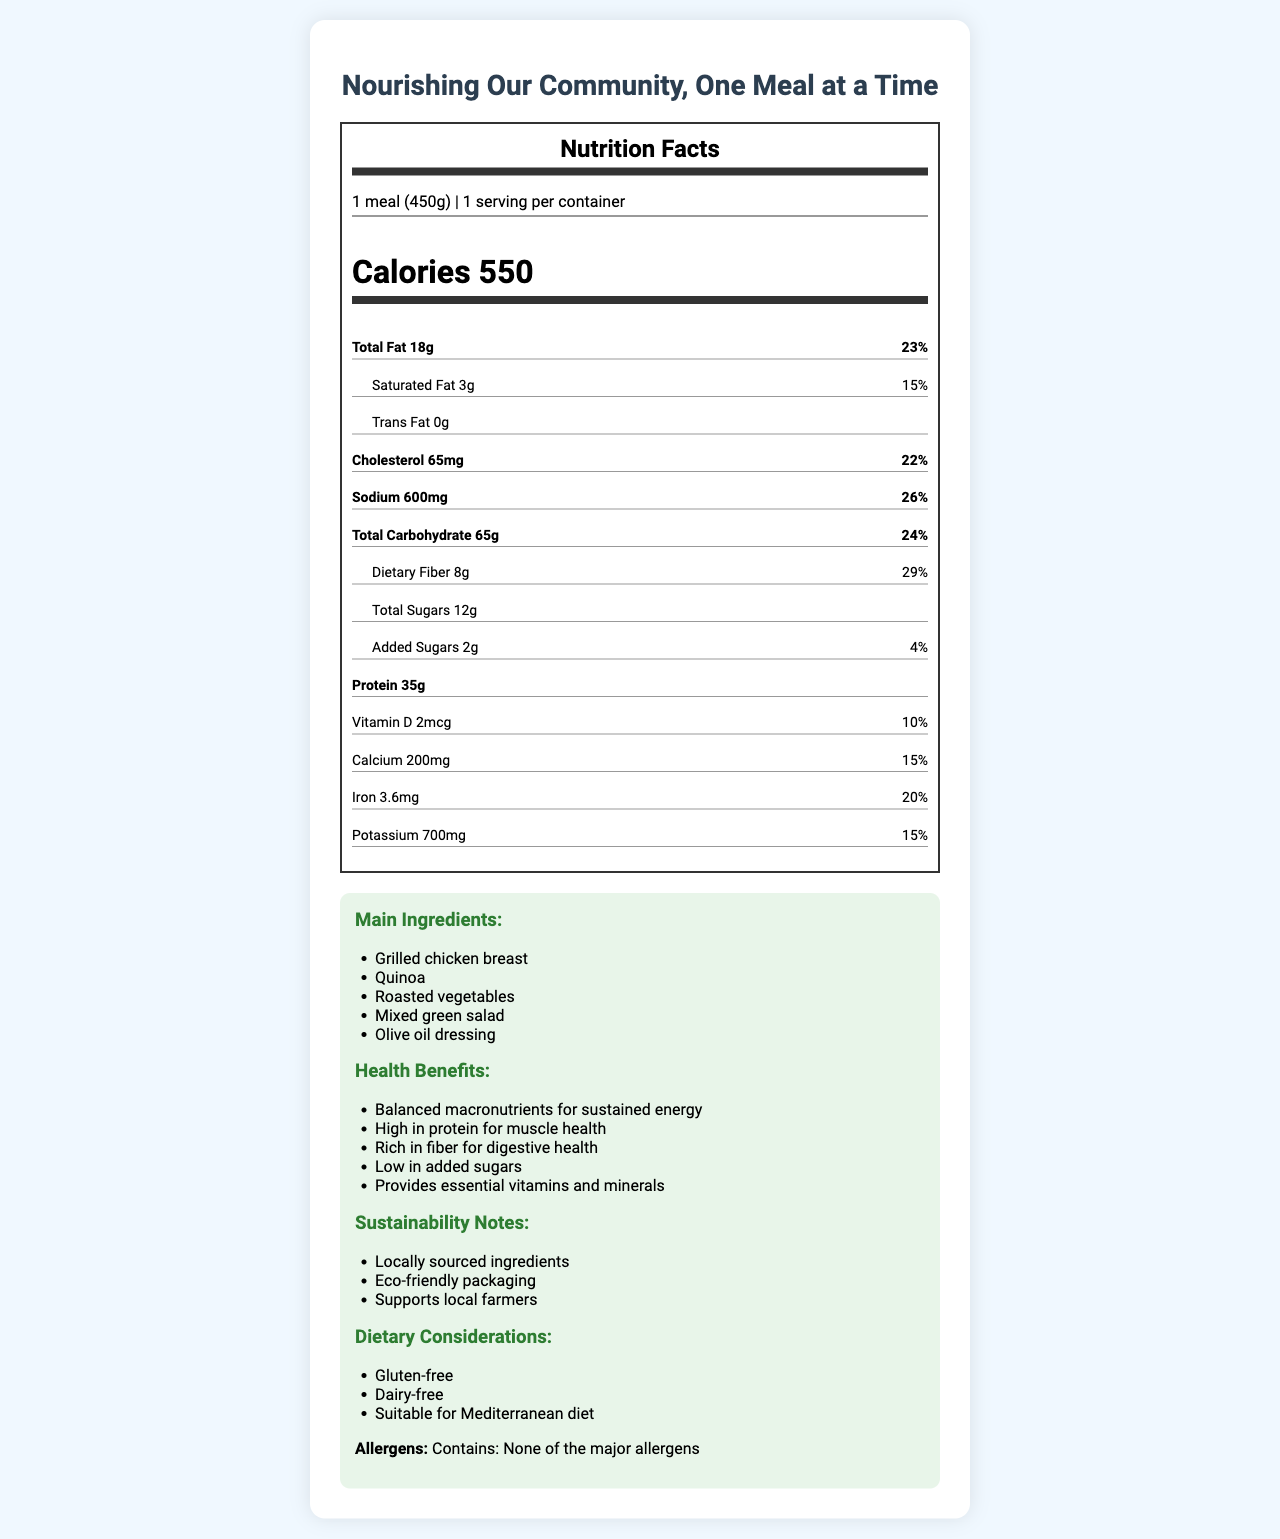what is the serving size? The serving size is mentioned at the top of the Nutrition Facts section as "1 meal (450g)".
Answer: 1 meal (450g) how many calories are in one serving? The number of calories per serving is shown in large bold text in the Nutrition Facts section, indicating 550 calories.
Answer: 550 what is the percentage daily value of sodium? The percentage daily value of sodium is given as 26% in the list of nutrients in the Nutrition Facts section.
Answer: 26% how much protein does the meal contain? The protein content is listed under the Nutrition Facts section as 35g.
Answer: 35g what are the main ingredients? The main ingredients are listed under the Campaign Info section of the document.
Answer: Grilled chicken breast, Quinoa, Roasted vegetables, Mixed green salad, Olive oil dressing how much dietary fiber is in the meal? The dietary fiber content is listed in the Nutrition Facts section as 8g.
Answer: 8g what is the percentage daily value of dietary fiber? The percentage daily value of dietary fiber is mentioned as 29% in the Nutrition Facts section.
Answer: 29% how much added sugar does the meal contain? A. 0g B. 2g C. 5g D. 12g The added sugars content is listed in the Nutrition Facts section as 2g.
Answer: B which of the following is true about the allergens? I. Contains: Dairy II. Contains: Nuts III. Contains: None of the major allergens IV. Contains: Gluten The allergen information in the Campaign Info section states "Contains: None of the major allergens".
Answer: III is the meal gluten-free? The dietary considerations in the Campaign Info section specify that the meal is gluten-free.
Answer: Yes describe the main idea of the document. The document is designed to present comprehensive nutritional information about a meal offered for campaign events. It highlights the nutritional content, ingredients, health benefits, and sustainability efforts, as well as dietary considerations and allergen information.
Answer: The document provides a detailed Nutrition Facts Label and additional campaign information for a healthy meal, including serving size, calories, macronutrient content, vitamins, minerals, main ingredients, health benefits, sustainability notes, and dietary considerations. does the meal include any major allergens? The allergen information clearly states "Contains: None of the major allergens."
Answer: No what is the brand of the meal? The document does not provide any information about the brand associated with the meal.
Answer: Cannot be determined 